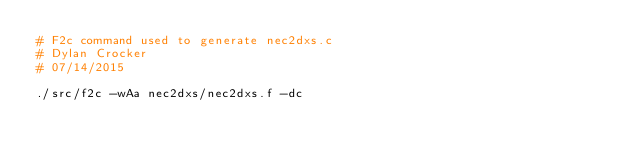<code> <loc_0><loc_0><loc_500><loc_500><_Bash_># F2c command used to generate nec2dxs.c
# Dylan Crocker
# 07/14/2015

./src/f2c -wAa nec2dxs/nec2dxs.f -dc
</code> 